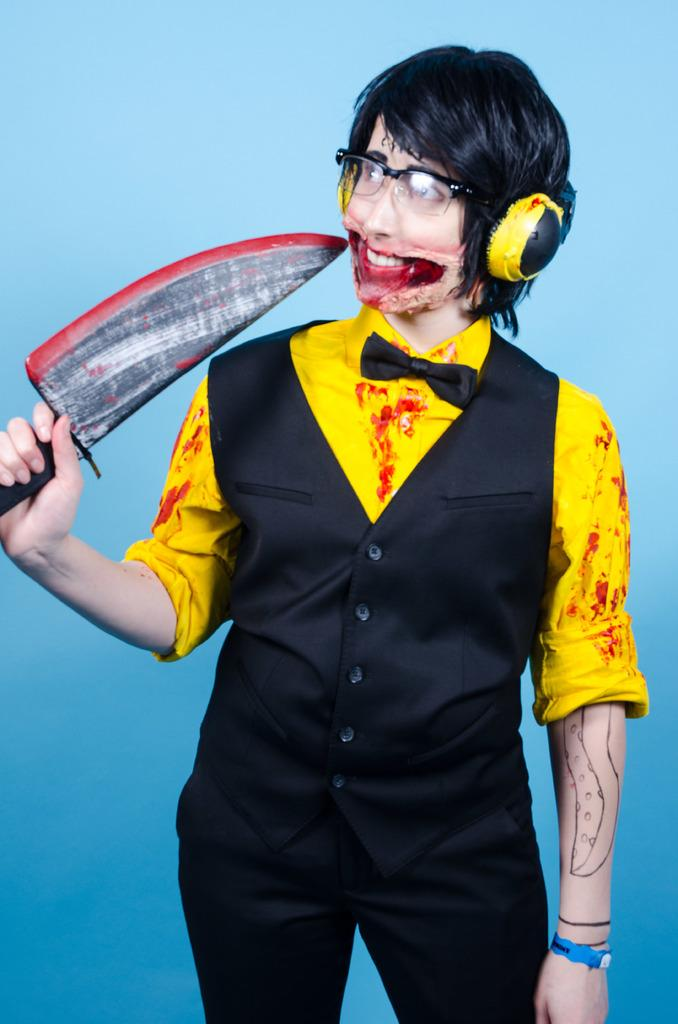Who is the main subject in the image? There is a person in the center of the image. What is the person wearing? The person is wearing a costume, glasses, and a headset. What is the person holding in the image? The person is holding a sword. What can be seen in the background of the image? There is a wall in the background of the image. What type of song is the person singing in the image? There is no indication in the image that the person is singing, so it cannot be determined from the picture. 